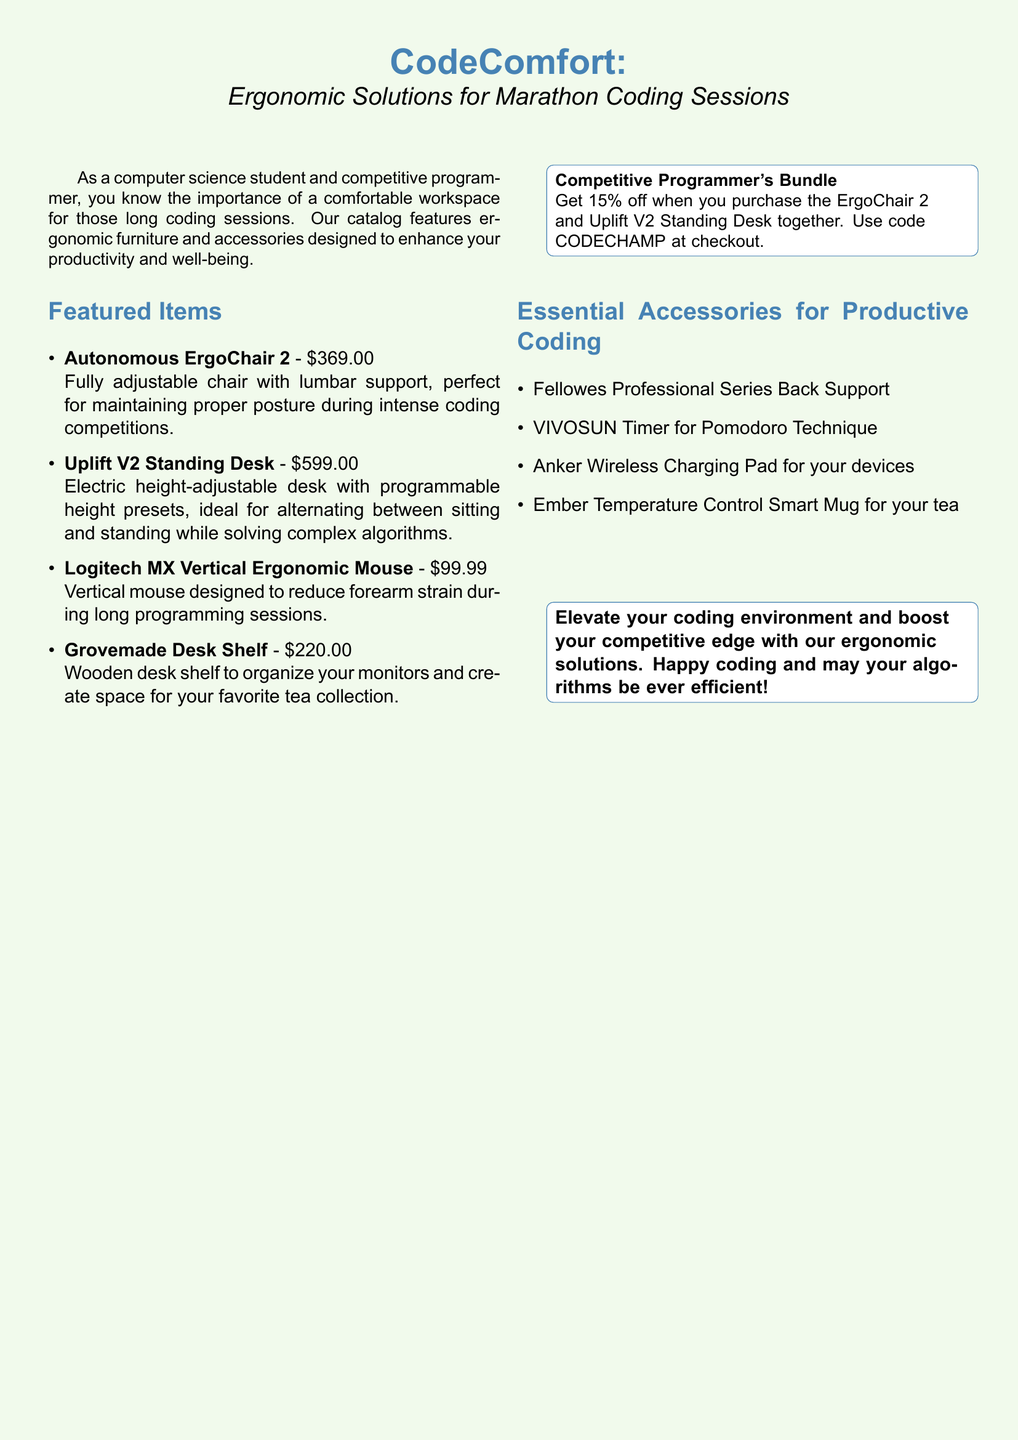What is the name of the featured chair? The document lists the Autonomous ErgoChair 2 as the featured chair for ergonomic support during coding.
Answer: Autonomous ErgoChair 2 What is the price of the Uplift V2 Standing Desk? The Uplift V2 Standing Desk is priced at $599 as mentioned in the catalog.
Answer: $599 What discount is offered for the Competitive Programmer's Bundle? The catalog states that there is a 15% off promotion when purchasing the ErgoChair 2 and Uplift V2 together.
Answer: 15% What is the function of the Ember Temperature Control Smart Mug? The mug is designed to control the temperature of your tea, ensuring it stays warm during coding sessions.
Answer: Temperature control Which accessory is suggested for organizing monitors? The Grovemade Desk Shelf is specifically mentioned as a solution for organizing monitors.
Answer: Grovemade Desk Shelf How much does the Logitech MX Vertical Ergonomic Mouse cost? The price listed for the Logitech MX Vertical Ergonomic Mouse is $99.99 in the catalog.
Answer: $99.99 